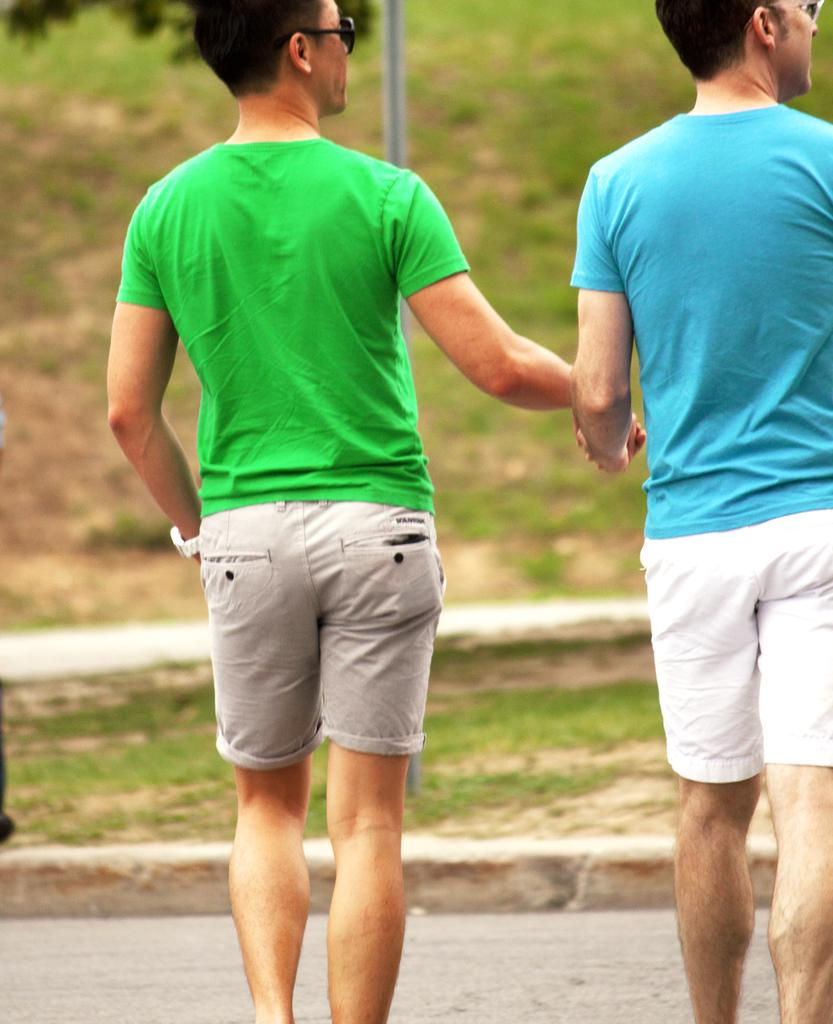How many people are in the image? There are two people in the image. What colors are the t-shirts worn by the people? One person is wearing a green t-shirt, and the other person is wearing a blue t-shirt. What type of surface can be seen in the image? There is grass visible in the image. How would you describe the background of the image? The background of the image is blurred. What type of bed can be seen in the image? There is no bed present in the image. Can you see any bubbles in the image? There are no bubbles visible in the image. 